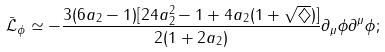Convert formula to latex. <formula><loc_0><loc_0><loc_500><loc_500>\bar { \mathcal { L } } _ { \phi } \simeq - \frac { 3 ( 6 a _ { 2 } - 1 ) [ 2 4 a _ { 2 } ^ { 2 } - 1 + 4 a _ { 2 } ( 1 + \sqrt { \diamondsuit } ) ] } { 2 ( 1 + 2 a _ { 2 } ) } \partial _ { \mu } \phi \partial ^ { \mu } \phi ;</formula> 